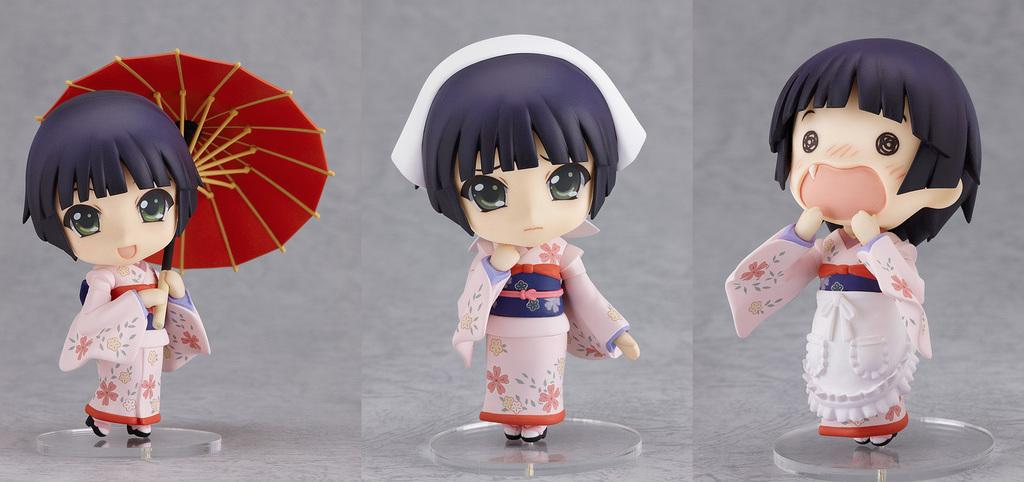How many toys are present in the image? There are three toys in the image. What is the color of the surface where the toys are placed? The toys are on an ash color surface. Which toy is holding an umbrella? One of the toys is holding an umbrella. What color is the umbrella being held by the toy? The umbrella is red in color. What type of behavior is the toy with the umbrella exhibiting in the image? The image does not provide information about the behavior of the toy with the umbrella. 